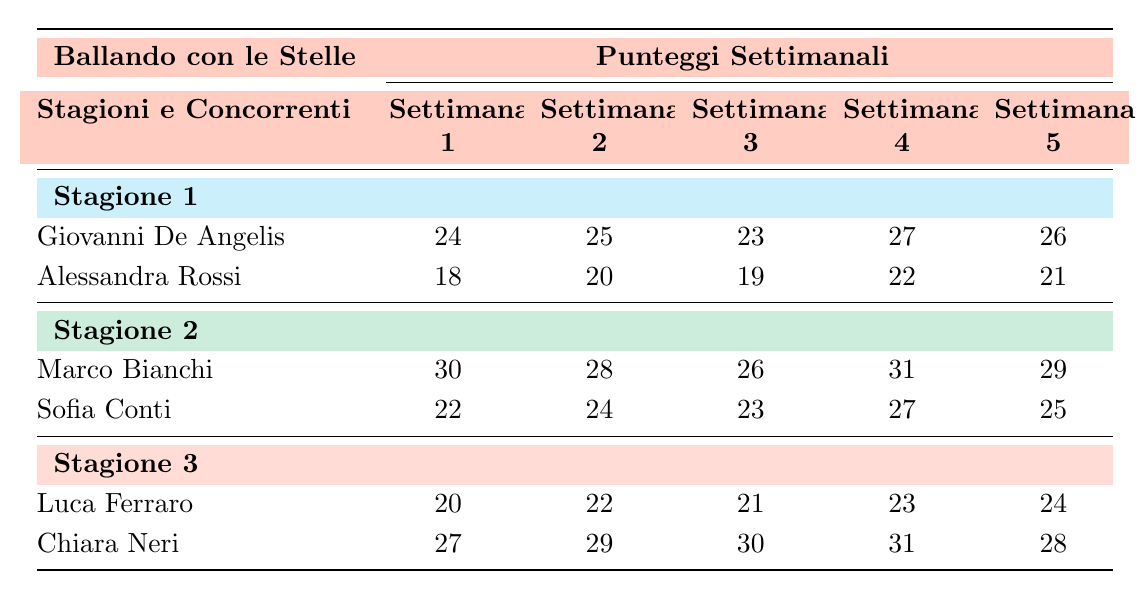What is the highest score achieved by Giovanni De Angelis in Season 1? Looking at the scores in Season 1 for Giovanni De Angelis, the highest score is 27, which he achieved in Week 4.
Answer: 27 What is the average score of Alessandra Rossi across all weeks in Season 1? To find the average, sum Alessandra Rossi's scores: 18 + 20 + 19 + 22 + 21 = 100. There are 5 weeks, so the average is 100/5 = 20.
Answer: 20 Did Marco Bianchi score the highest in Week 3 of Season 2? In Week 3 of Season 2, Marco Bianchi scored 26, while Sofia Conti scored 23. Therefore, Marco Bianchi did have the highest score in that week.
Answer: Yes What is the score difference between Chiara Neri's Week 1 and Week 5 scores in Season 3? Chiara Neri's Week 1 score is 27 and her Week 5 score is 28. The difference is calculated as 28 - 27 = 1.
Answer: 1 What is the total score achieved by Luca Ferraro in Season 3? The total score for Luca Ferraro is calculated by summing his scores for each week: 20 + 22 + 21 + 23 + 24 = 110.
Answer: 110 Which contestant scored the lowest score in Week 2 across all seasons? In Week 2, Giovanni De Angelis scored 25, Alessandra Rossi scored 20, Marco Bianchi scored 28, Sofia Conti scored 24, Luca Ferraro scored 22, and Chiara Neri scored 29. The lowest score is 20 from Alessandra Rossi.
Answer: Alessandra Rossi What was the score trend for Marco Bianchi from Week 1 to Week 5 in Season 2? Analyzing Marco Bianchi's scores: Week 1 (30), Week 2 (28), Week 3 (26), Week 4 (31), Week 5 (29). The trend shows a decrease from Week 1 to Week 3, followed by an increase in Week 4, and a slight decrease again in Week 5.
Answer: Decrease then Increase What is the contestant with the highest total score from all weeks in Season 3? Total scores for Season 3: Luca Ferraro = 110, Chiara Neri = 145 (27 + 29 + 30 + 31 + 28). Chiara Neri has the highest total score among the contestants.
Answer: Chiara Neri 